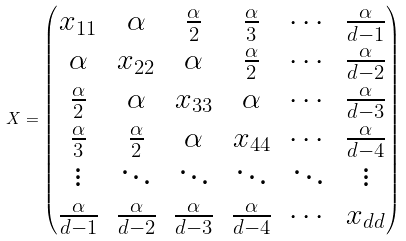Convert formula to latex. <formula><loc_0><loc_0><loc_500><loc_500>X = \begin{pmatrix} x _ { 1 1 } & \alpha & \frac { \alpha } { 2 } & \frac { \alpha } { 3 } & \cdots & \frac { \alpha } { d - 1 } \\ \alpha & x _ { 2 2 } & \alpha & \frac { \alpha } { 2 } & \cdots & \frac { \alpha } { d - 2 } \\ \frac { \alpha } { 2 } & \alpha & x _ { 3 3 } & \alpha & \cdots & \frac { \alpha } { d - 3 } \\ \frac { \alpha } { 3 } & \frac { \alpha } { 2 } & \alpha & x _ { 4 4 } & \cdots & \frac { \alpha } { d - 4 } \\ \vdots & \ddots & \ddots & \ddots & \ddots & \vdots \\ \frac { \alpha } { d - 1 } & \frac { \alpha } { d - 2 } & \frac { \alpha } { d - 3 } & \frac { \alpha } { d - 4 } & \cdots & x _ { d d } \end{pmatrix}</formula> 